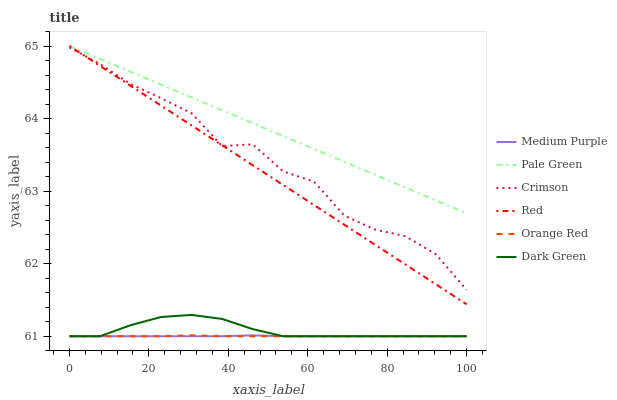Does Medium Purple have the minimum area under the curve?
Answer yes or no. Yes. Does Pale Green have the maximum area under the curve?
Answer yes or no. Yes. Does Crimson have the minimum area under the curve?
Answer yes or no. No. Does Crimson have the maximum area under the curve?
Answer yes or no. No. Is Pale Green the smoothest?
Answer yes or no. Yes. Is Crimson the roughest?
Answer yes or no. Yes. Is Crimson the smoothest?
Answer yes or no. No. Is Pale Green the roughest?
Answer yes or no. No. Does Medium Purple have the lowest value?
Answer yes or no. Yes. Does Crimson have the lowest value?
Answer yes or no. No. Does Red have the highest value?
Answer yes or no. Yes. Does Crimson have the highest value?
Answer yes or no. No. Is Orange Red less than Crimson?
Answer yes or no. Yes. Is Pale Green greater than Dark Green?
Answer yes or no. Yes. Does Crimson intersect Red?
Answer yes or no. Yes. Is Crimson less than Red?
Answer yes or no. No. Is Crimson greater than Red?
Answer yes or no. No. Does Orange Red intersect Crimson?
Answer yes or no. No. 